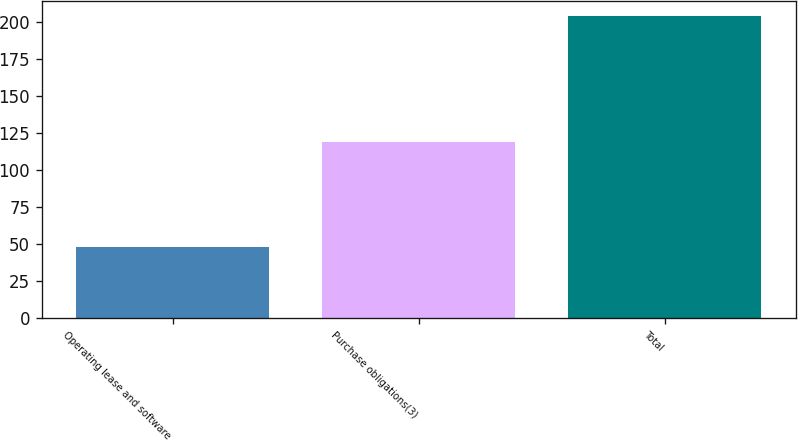Convert chart. <chart><loc_0><loc_0><loc_500><loc_500><bar_chart><fcel>Operating lease and software<fcel>Purchase obligations(3)<fcel>Total<nl><fcel>47.7<fcel>119.1<fcel>204.2<nl></chart> 